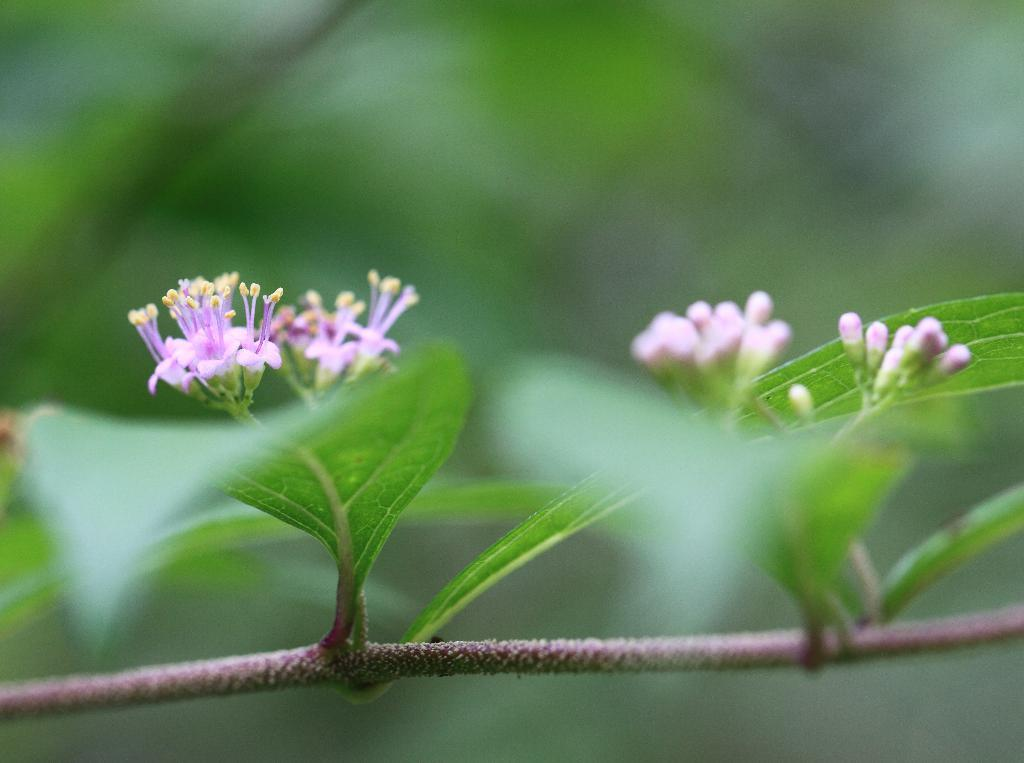What part of a plant is visible in the image? There is a stem of a plant in the image. What features can be seen on the stem? The stem has leaves, flowers, and buds. How would you describe the background of the image? The background of the image is blurry. What type of punishment is being given to the thing in the image? There is no punishment or thing present in the image; it features a stem of a plant with leaves, flowers, and buds against a blurry background. 